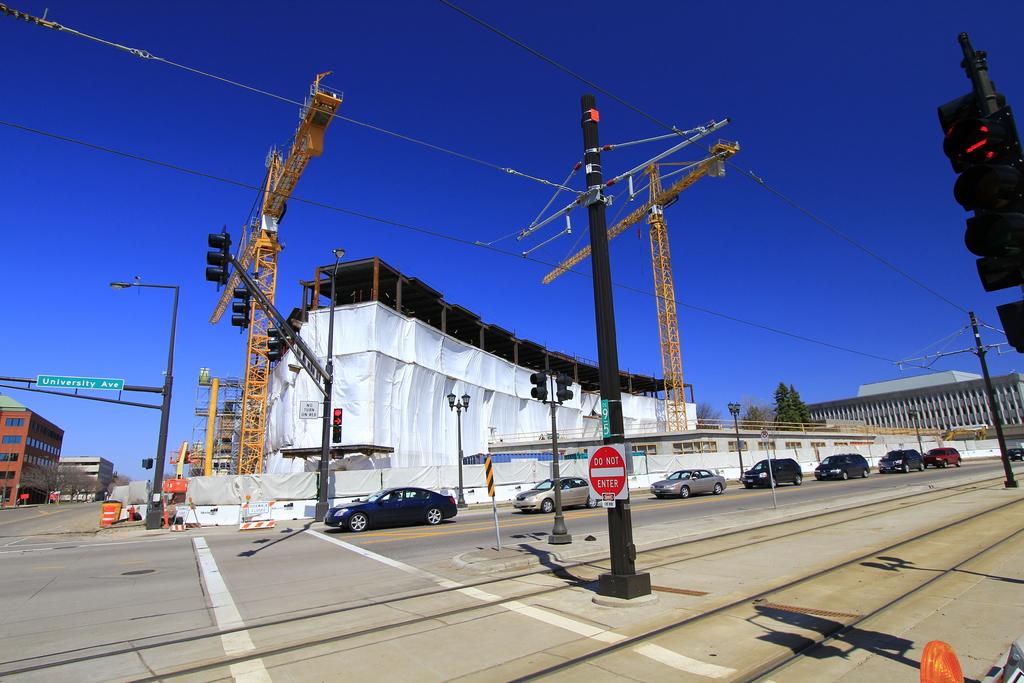What does the red sign say?
Ensure brevity in your answer.  Do not enter. Where can some one not do according to the stop sign?
Ensure brevity in your answer.  Enter. 